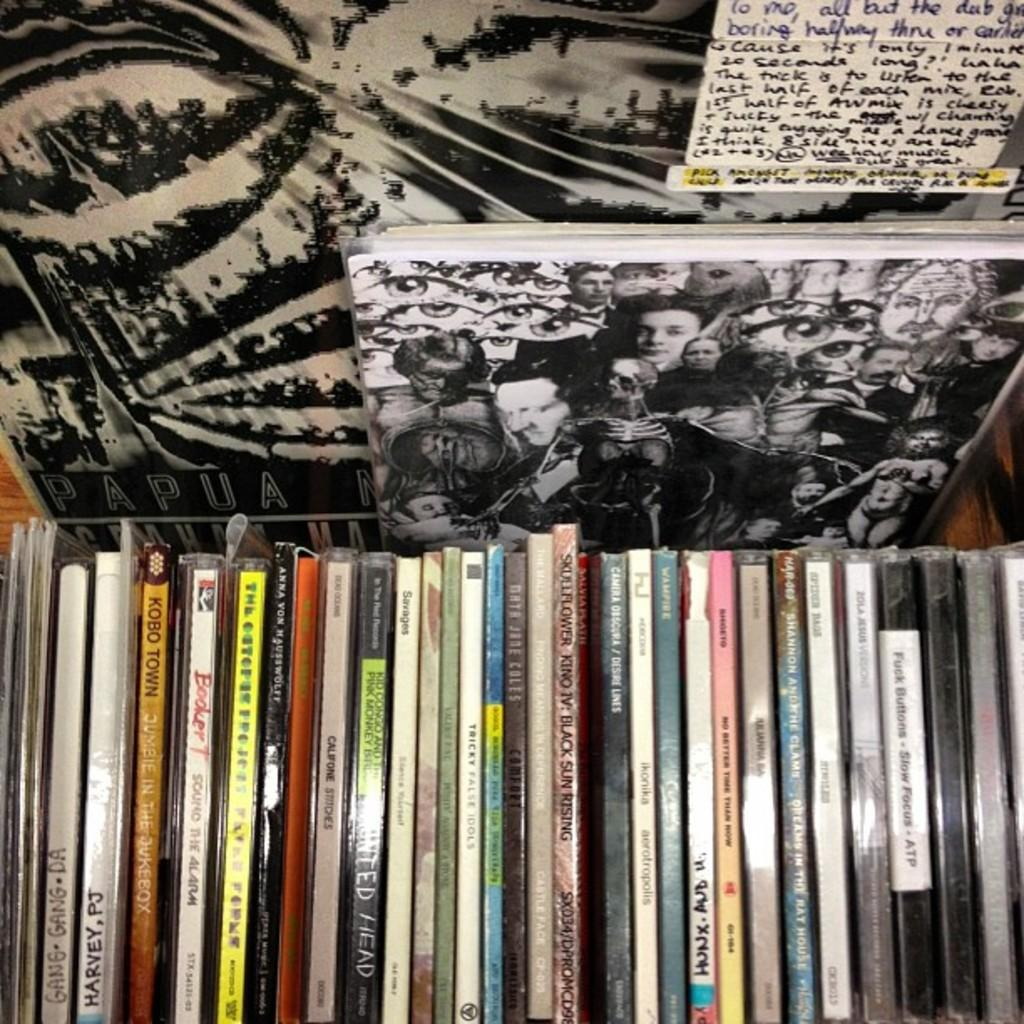<image>
Create a compact narrative representing the image presented. Books sitting in front of a photograph that has PAPUA in large white block letters. 